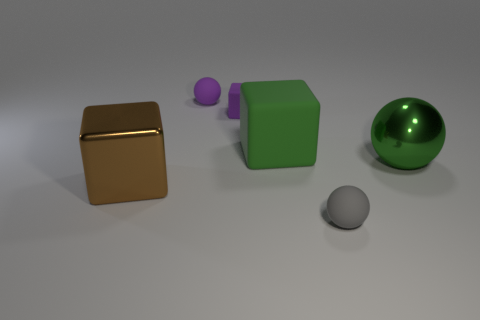Are there any tiny objects made of the same material as the purple ball? Yes, there is a small gray sphere that appears to be made of the same material as the purple ball, which suggests they could both be made from a similar plastic or resin. 